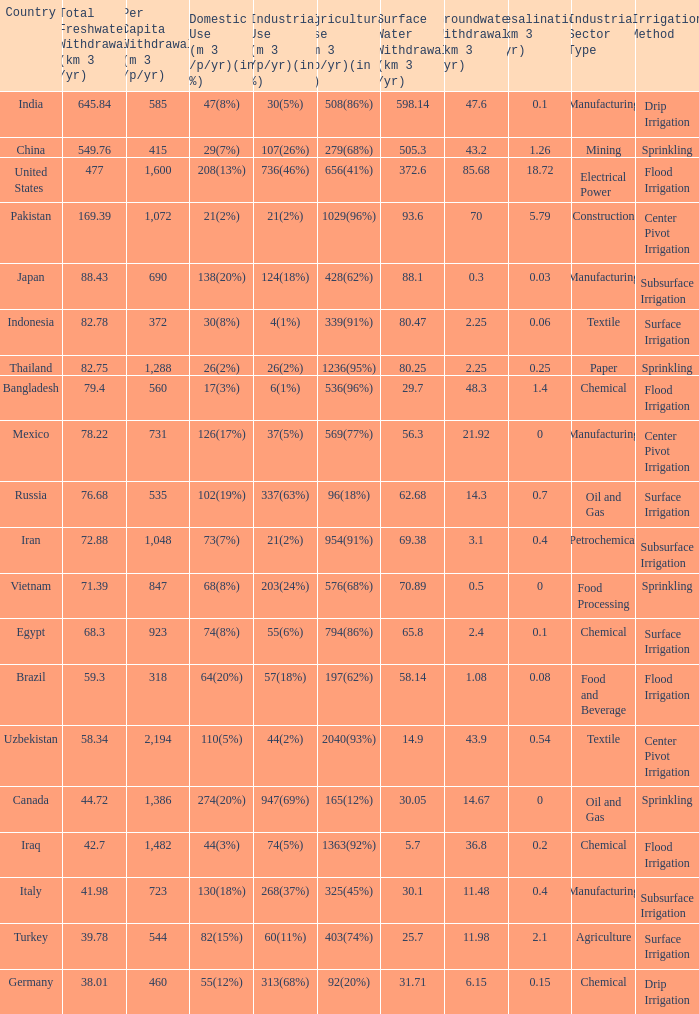What is the average Total Freshwater Withdrawal (km 3 /yr), when Industrial Use (m 3 /p/yr)(in %) is 337(63%), and when Per Capita Withdrawal (m 3 /p/yr) is greater than 535? None. 